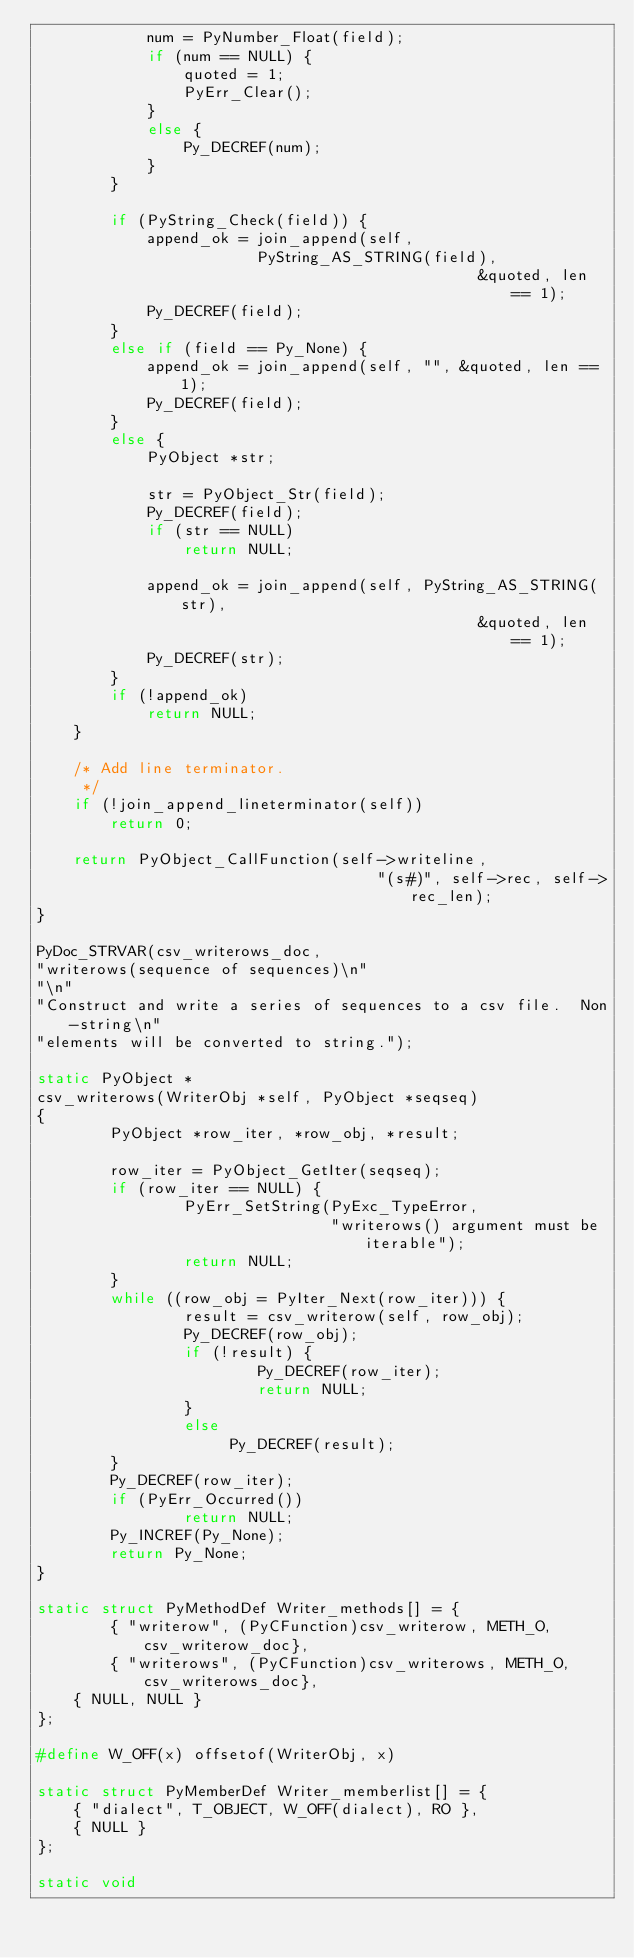<code> <loc_0><loc_0><loc_500><loc_500><_C_>			num = PyNumber_Float(field);
			if (num == NULL) {
				quoted = 1;
				PyErr_Clear();
			}
			else {
				Py_DECREF(num);
			}
		}

		if (PyString_Check(field)) {
			append_ok = join_append(self,
						PyString_AS_STRING(field),
                                                &quoted, len == 1);
			Py_DECREF(field);
		}
		else if (field == Py_None) {
			append_ok = join_append(self, "", &quoted, len == 1);
			Py_DECREF(field);
		}
		else {
			PyObject *str;

			str = PyObject_Str(field);
			Py_DECREF(field);
			if (str == NULL)
				return NULL;

			append_ok = join_append(self, PyString_AS_STRING(str), 
                                                &quoted, len == 1);
			Py_DECREF(str);
		}
		if (!append_ok)
			return NULL;
	}

	/* Add line terminator.
	 */
	if (!join_append_lineterminator(self))
		return 0;

	return PyObject_CallFunction(self->writeline, 
                                     "(s#)", self->rec, self->rec_len);
}

PyDoc_STRVAR(csv_writerows_doc,
"writerows(sequence of sequences)\n"
"\n"
"Construct and write a series of sequences to a csv file.  Non-string\n"
"elements will be converted to string.");

static PyObject *
csv_writerows(WriterObj *self, PyObject *seqseq)
{
        PyObject *row_iter, *row_obj, *result;

        row_iter = PyObject_GetIter(seqseq);
        if (row_iter == NULL) {
                PyErr_SetString(PyExc_TypeError,
                                "writerows() argument must be iterable");
                return NULL;
        }
        while ((row_obj = PyIter_Next(row_iter))) {
                result = csv_writerow(self, row_obj);
                Py_DECREF(row_obj);
                if (!result) {
                        Py_DECREF(row_iter);
                        return NULL;
                }
                else
                     Py_DECREF(result);   
        }
        Py_DECREF(row_iter);
        if (PyErr_Occurred())
                return NULL;
        Py_INCREF(Py_None);
        return Py_None;
}

static struct PyMethodDef Writer_methods[] = {
        { "writerow", (PyCFunction)csv_writerow, METH_O, csv_writerow_doc},
        { "writerows", (PyCFunction)csv_writerows, METH_O, csv_writerows_doc},
	{ NULL, NULL }
};

#define W_OFF(x) offsetof(WriterObj, x)

static struct PyMemberDef Writer_memberlist[] = {
	{ "dialect", T_OBJECT, W_OFF(dialect), RO },
	{ NULL }
};

static void</code> 